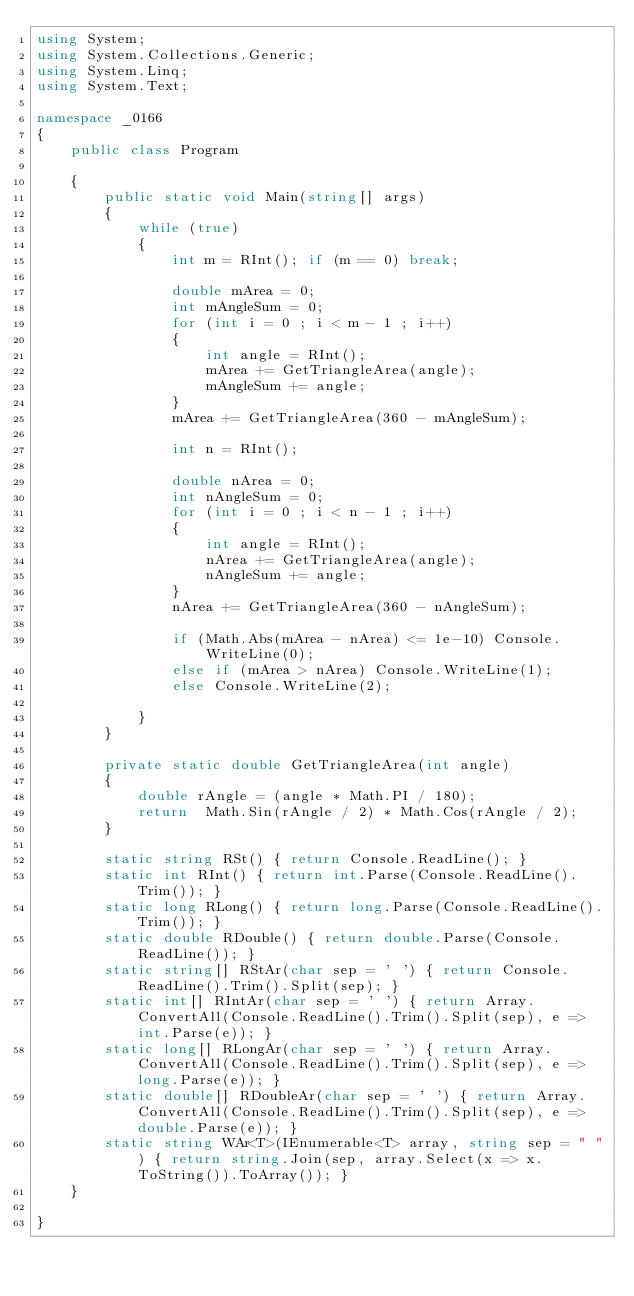Convert code to text. <code><loc_0><loc_0><loc_500><loc_500><_C#_>using System;
using System.Collections.Generic;
using System.Linq;
using System.Text;

namespace _0166
{
    public class Program

    {
        public static void Main(string[] args)
        {
            while (true)
            {
                int m = RInt(); if (m == 0) break;

                double mArea = 0;
                int mAngleSum = 0;
                for (int i = 0 ; i < m - 1 ; i++)
                {
                    int angle = RInt();
                    mArea += GetTriangleArea(angle);
                    mAngleSum += angle;
                }
                mArea += GetTriangleArea(360 - mAngleSum);

                int n = RInt();

                double nArea = 0;
                int nAngleSum = 0;
                for (int i = 0 ; i < n - 1 ; i++)
                {
                    int angle = RInt();
                    nArea += GetTriangleArea(angle);
                    nAngleSum += angle;
                }
                nArea += GetTriangleArea(360 - nAngleSum);

                if (Math.Abs(mArea - nArea) <= 1e-10) Console.WriteLine(0);
                else if (mArea > nArea) Console.WriteLine(1);
                else Console.WriteLine(2);

            }
        }

        private static double GetTriangleArea(int angle)
        {
            double rAngle = (angle * Math.PI / 180);
            return  Math.Sin(rAngle / 2) * Math.Cos(rAngle / 2);
        }

        static string RSt() { return Console.ReadLine(); }
        static int RInt() { return int.Parse(Console.ReadLine().Trim()); }
        static long RLong() { return long.Parse(Console.ReadLine().Trim()); }
        static double RDouble() { return double.Parse(Console.ReadLine()); }
        static string[] RStAr(char sep = ' ') { return Console.ReadLine().Trim().Split(sep); }
        static int[] RIntAr(char sep = ' ') { return Array.ConvertAll(Console.ReadLine().Trim().Split(sep), e => int.Parse(e)); }
        static long[] RLongAr(char sep = ' ') { return Array.ConvertAll(Console.ReadLine().Trim().Split(sep), e => long.Parse(e)); }
        static double[] RDoubleAr(char sep = ' ') { return Array.ConvertAll(Console.ReadLine().Trim().Split(sep), e => double.Parse(e)); }
        static string WAr<T>(IEnumerable<T> array, string sep = " ") { return string.Join(sep, array.Select(x => x.ToString()).ToArray()); }
    }

}

</code> 